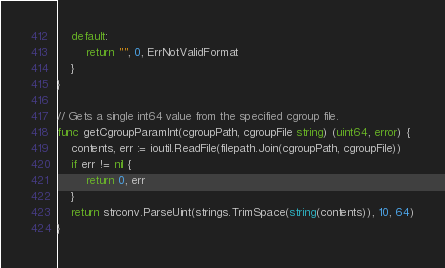<code> <loc_0><loc_0><loc_500><loc_500><_Go_>	default:
		return "", 0, ErrNotValidFormat
	}
}

// Gets a single int64 value from the specified cgroup file.
func getCgroupParamInt(cgroupPath, cgroupFile string) (uint64, error) {
	contents, err := ioutil.ReadFile(filepath.Join(cgroupPath, cgroupFile))
	if err != nil {
		return 0, err
	}
	return strconv.ParseUint(strings.TrimSpace(string(contents)), 10, 64)
}
</code> 